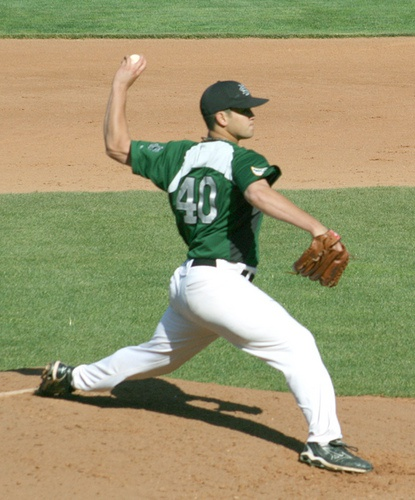Describe the objects in this image and their specific colors. I can see people in green, white, black, gray, and darkgreen tones, baseball glove in green, maroon, brown, and gray tones, and sports ball in ivory, tan, and green tones in this image. 